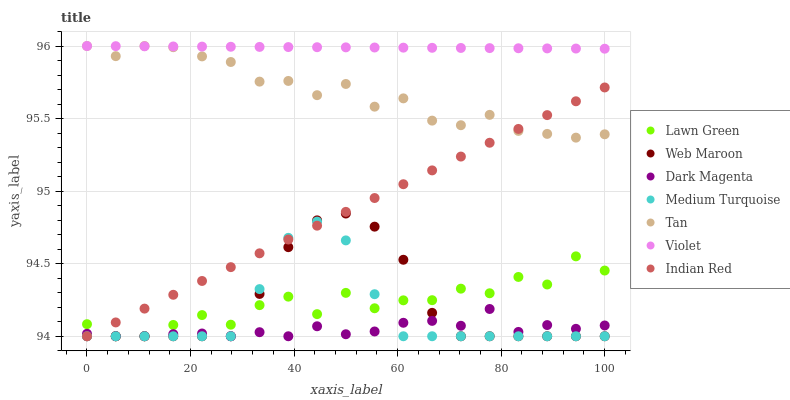Does Dark Magenta have the minimum area under the curve?
Answer yes or no. Yes. Does Violet have the maximum area under the curve?
Answer yes or no. Yes. Does Web Maroon have the minimum area under the curve?
Answer yes or no. No. Does Web Maroon have the maximum area under the curve?
Answer yes or no. No. Is Violet the smoothest?
Answer yes or no. Yes. Is Lawn Green the roughest?
Answer yes or no. Yes. Is Dark Magenta the smoothest?
Answer yes or no. No. Is Dark Magenta the roughest?
Answer yes or no. No. Does Lawn Green have the lowest value?
Answer yes or no. Yes. Does Violet have the lowest value?
Answer yes or no. No. Does Tan have the highest value?
Answer yes or no. Yes. Does Web Maroon have the highest value?
Answer yes or no. No. Is Dark Magenta less than Tan?
Answer yes or no. Yes. Is Violet greater than Lawn Green?
Answer yes or no. Yes. Does Dark Magenta intersect Indian Red?
Answer yes or no. Yes. Is Dark Magenta less than Indian Red?
Answer yes or no. No. Is Dark Magenta greater than Indian Red?
Answer yes or no. No. Does Dark Magenta intersect Tan?
Answer yes or no. No. 